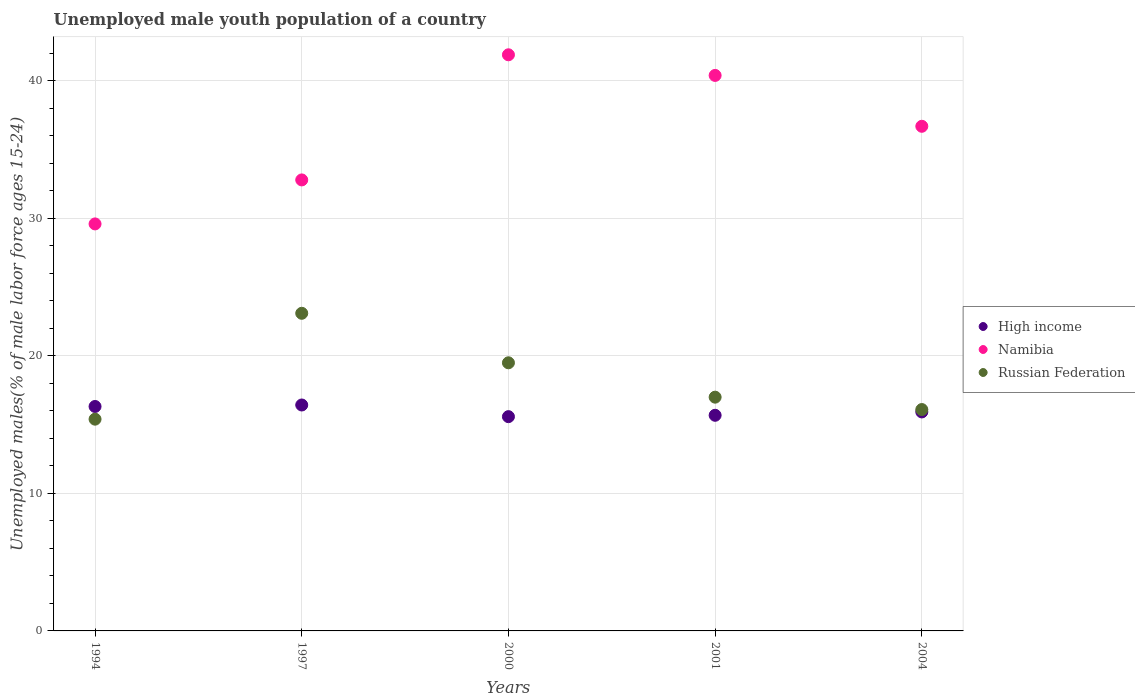Is the number of dotlines equal to the number of legend labels?
Ensure brevity in your answer.  Yes. What is the percentage of unemployed male youth population in High income in 2000?
Your response must be concise. 15.58. Across all years, what is the maximum percentage of unemployed male youth population in High income?
Give a very brief answer. 16.43. Across all years, what is the minimum percentage of unemployed male youth population in High income?
Provide a succinct answer. 15.58. What is the total percentage of unemployed male youth population in High income in the graph?
Offer a terse response. 79.95. What is the difference between the percentage of unemployed male youth population in Russian Federation in 1994 and that in 2000?
Ensure brevity in your answer.  -4.1. What is the difference between the percentage of unemployed male youth population in High income in 2001 and the percentage of unemployed male youth population in Namibia in 2000?
Give a very brief answer. -26.22. What is the average percentage of unemployed male youth population in Russian Federation per year?
Your answer should be compact. 18.22. In the year 1997, what is the difference between the percentage of unemployed male youth population in Russian Federation and percentage of unemployed male youth population in High income?
Make the answer very short. 6.67. In how many years, is the percentage of unemployed male youth population in Russian Federation greater than 12 %?
Ensure brevity in your answer.  5. What is the ratio of the percentage of unemployed male youth population in Russian Federation in 1994 to that in 2000?
Offer a very short reply. 0.79. What is the difference between the highest and the second highest percentage of unemployed male youth population in Russian Federation?
Your answer should be compact. 3.6. What is the difference between the highest and the lowest percentage of unemployed male youth population in Namibia?
Your answer should be very brief. 12.3. Is the sum of the percentage of unemployed male youth population in Namibia in 2000 and 2004 greater than the maximum percentage of unemployed male youth population in High income across all years?
Your response must be concise. Yes. Is the percentage of unemployed male youth population in High income strictly less than the percentage of unemployed male youth population in Namibia over the years?
Your response must be concise. Yes. How many years are there in the graph?
Make the answer very short. 5. What is the difference between two consecutive major ticks on the Y-axis?
Offer a very short reply. 10. Does the graph contain any zero values?
Ensure brevity in your answer.  No. Does the graph contain grids?
Make the answer very short. Yes. Where does the legend appear in the graph?
Your answer should be compact. Center right. How are the legend labels stacked?
Provide a short and direct response. Vertical. What is the title of the graph?
Your response must be concise. Unemployed male youth population of a country. Does "Norway" appear as one of the legend labels in the graph?
Provide a short and direct response. No. What is the label or title of the X-axis?
Keep it short and to the point. Years. What is the label or title of the Y-axis?
Give a very brief answer. Unemployed males(% of male labor force ages 15-24). What is the Unemployed males(% of male labor force ages 15-24) of High income in 1994?
Offer a terse response. 16.32. What is the Unemployed males(% of male labor force ages 15-24) in Namibia in 1994?
Provide a short and direct response. 29.6. What is the Unemployed males(% of male labor force ages 15-24) in Russian Federation in 1994?
Your answer should be very brief. 15.4. What is the Unemployed males(% of male labor force ages 15-24) in High income in 1997?
Keep it short and to the point. 16.43. What is the Unemployed males(% of male labor force ages 15-24) in Namibia in 1997?
Ensure brevity in your answer.  32.8. What is the Unemployed males(% of male labor force ages 15-24) of Russian Federation in 1997?
Make the answer very short. 23.1. What is the Unemployed males(% of male labor force ages 15-24) of High income in 2000?
Your answer should be compact. 15.58. What is the Unemployed males(% of male labor force ages 15-24) in Namibia in 2000?
Offer a very short reply. 41.9. What is the Unemployed males(% of male labor force ages 15-24) in High income in 2001?
Your answer should be compact. 15.68. What is the Unemployed males(% of male labor force ages 15-24) of Namibia in 2001?
Keep it short and to the point. 40.4. What is the Unemployed males(% of male labor force ages 15-24) of Russian Federation in 2001?
Offer a very short reply. 17. What is the Unemployed males(% of male labor force ages 15-24) in High income in 2004?
Make the answer very short. 15.93. What is the Unemployed males(% of male labor force ages 15-24) in Namibia in 2004?
Your response must be concise. 36.7. What is the Unemployed males(% of male labor force ages 15-24) of Russian Federation in 2004?
Your response must be concise. 16.1. Across all years, what is the maximum Unemployed males(% of male labor force ages 15-24) in High income?
Provide a succinct answer. 16.43. Across all years, what is the maximum Unemployed males(% of male labor force ages 15-24) of Namibia?
Your answer should be very brief. 41.9. Across all years, what is the maximum Unemployed males(% of male labor force ages 15-24) in Russian Federation?
Offer a terse response. 23.1. Across all years, what is the minimum Unemployed males(% of male labor force ages 15-24) of High income?
Ensure brevity in your answer.  15.58. Across all years, what is the minimum Unemployed males(% of male labor force ages 15-24) in Namibia?
Your answer should be compact. 29.6. Across all years, what is the minimum Unemployed males(% of male labor force ages 15-24) in Russian Federation?
Ensure brevity in your answer.  15.4. What is the total Unemployed males(% of male labor force ages 15-24) in High income in the graph?
Offer a very short reply. 79.95. What is the total Unemployed males(% of male labor force ages 15-24) of Namibia in the graph?
Your response must be concise. 181.4. What is the total Unemployed males(% of male labor force ages 15-24) of Russian Federation in the graph?
Give a very brief answer. 91.1. What is the difference between the Unemployed males(% of male labor force ages 15-24) of High income in 1994 and that in 1997?
Give a very brief answer. -0.11. What is the difference between the Unemployed males(% of male labor force ages 15-24) of High income in 1994 and that in 2000?
Your answer should be compact. 0.74. What is the difference between the Unemployed males(% of male labor force ages 15-24) of Russian Federation in 1994 and that in 2000?
Your response must be concise. -4.1. What is the difference between the Unemployed males(% of male labor force ages 15-24) in High income in 1994 and that in 2001?
Keep it short and to the point. 0.64. What is the difference between the Unemployed males(% of male labor force ages 15-24) in High income in 1994 and that in 2004?
Your answer should be compact. 0.4. What is the difference between the Unemployed males(% of male labor force ages 15-24) of High income in 1997 and that in 2000?
Your answer should be compact. 0.85. What is the difference between the Unemployed males(% of male labor force ages 15-24) in High income in 1997 and that in 2001?
Your answer should be compact. 0.75. What is the difference between the Unemployed males(% of male labor force ages 15-24) in Namibia in 1997 and that in 2001?
Provide a succinct answer. -7.6. What is the difference between the Unemployed males(% of male labor force ages 15-24) of High income in 1997 and that in 2004?
Provide a short and direct response. 0.51. What is the difference between the Unemployed males(% of male labor force ages 15-24) in Russian Federation in 1997 and that in 2004?
Offer a very short reply. 7. What is the difference between the Unemployed males(% of male labor force ages 15-24) in High income in 2000 and that in 2001?
Your answer should be compact. -0.1. What is the difference between the Unemployed males(% of male labor force ages 15-24) in Namibia in 2000 and that in 2001?
Offer a terse response. 1.5. What is the difference between the Unemployed males(% of male labor force ages 15-24) in Russian Federation in 2000 and that in 2001?
Your answer should be compact. 2.5. What is the difference between the Unemployed males(% of male labor force ages 15-24) of High income in 2000 and that in 2004?
Offer a very short reply. -0.34. What is the difference between the Unemployed males(% of male labor force ages 15-24) of Namibia in 2000 and that in 2004?
Provide a succinct answer. 5.2. What is the difference between the Unemployed males(% of male labor force ages 15-24) of Russian Federation in 2000 and that in 2004?
Keep it short and to the point. 3.4. What is the difference between the Unemployed males(% of male labor force ages 15-24) in High income in 2001 and that in 2004?
Provide a short and direct response. -0.24. What is the difference between the Unemployed males(% of male labor force ages 15-24) in Russian Federation in 2001 and that in 2004?
Provide a short and direct response. 0.9. What is the difference between the Unemployed males(% of male labor force ages 15-24) in High income in 1994 and the Unemployed males(% of male labor force ages 15-24) in Namibia in 1997?
Offer a terse response. -16.48. What is the difference between the Unemployed males(% of male labor force ages 15-24) in High income in 1994 and the Unemployed males(% of male labor force ages 15-24) in Russian Federation in 1997?
Make the answer very short. -6.78. What is the difference between the Unemployed males(% of male labor force ages 15-24) of High income in 1994 and the Unemployed males(% of male labor force ages 15-24) of Namibia in 2000?
Provide a short and direct response. -25.58. What is the difference between the Unemployed males(% of male labor force ages 15-24) of High income in 1994 and the Unemployed males(% of male labor force ages 15-24) of Russian Federation in 2000?
Ensure brevity in your answer.  -3.18. What is the difference between the Unemployed males(% of male labor force ages 15-24) in High income in 1994 and the Unemployed males(% of male labor force ages 15-24) in Namibia in 2001?
Make the answer very short. -24.08. What is the difference between the Unemployed males(% of male labor force ages 15-24) in High income in 1994 and the Unemployed males(% of male labor force ages 15-24) in Russian Federation in 2001?
Your answer should be very brief. -0.68. What is the difference between the Unemployed males(% of male labor force ages 15-24) in Namibia in 1994 and the Unemployed males(% of male labor force ages 15-24) in Russian Federation in 2001?
Give a very brief answer. 12.6. What is the difference between the Unemployed males(% of male labor force ages 15-24) in High income in 1994 and the Unemployed males(% of male labor force ages 15-24) in Namibia in 2004?
Offer a very short reply. -20.38. What is the difference between the Unemployed males(% of male labor force ages 15-24) in High income in 1994 and the Unemployed males(% of male labor force ages 15-24) in Russian Federation in 2004?
Provide a succinct answer. 0.22. What is the difference between the Unemployed males(% of male labor force ages 15-24) in Namibia in 1994 and the Unemployed males(% of male labor force ages 15-24) in Russian Federation in 2004?
Keep it short and to the point. 13.5. What is the difference between the Unemployed males(% of male labor force ages 15-24) of High income in 1997 and the Unemployed males(% of male labor force ages 15-24) of Namibia in 2000?
Ensure brevity in your answer.  -25.47. What is the difference between the Unemployed males(% of male labor force ages 15-24) of High income in 1997 and the Unemployed males(% of male labor force ages 15-24) of Russian Federation in 2000?
Offer a terse response. -3.07. What is the difference between the Unemployed males(% of male labor force ages 15-24) of High income in 1997 and the Unemployed males(% of male labor force ages 15-24) of Namibia in 2001?
Provide a succinct answer. -23.97. What is the difference between the Unemployed males(% of male labor force ages 15-24) in High income in 1997 and the Unemployed males(% of male labor force ages 15-24) in Russian Federation in 2001?
Give a very brief answer. -0.57. What is the difference between the Unemployed males(% of male labor force ages 15-24) of Namibia in 1997 and the Unemployed males(% of male labor force ages 15-24) of Russian Federation in 2001?
Your answer should be compact. 15.8. What is the difference between the Unemployed males(% of male labor force ages 15-24) of High income in 1997 and the Unemployed males(% of male labor force ages 15-24) of Namibia in 2004?
Make the answer very short. -20.27. What is the difference between the Unemployed males(% of male labor force ages 15-24) of High income in 1997 and the Unemployed males(% of male labor force ages 15-24) of Russian Federation in 2004?
Ensure brevity in your answer.  0.33. What is the difference between the Unemployed males(% of male labor force ages 15-24) of Namibia in 1997 and the Unemployed males(% of male labor force ages 15-24) of Russian Federation in 2004?
Your answer should be very brief. 16.7. What is the difference between the Unemployed males(% of male labor force ages 15-24) of High income in 2000 and the Unemployed males(% of male labor force ages 15-24) of Namibia in 2001?
Give a very brief answer. -24.82. What is the difference between the Unemployed males(% of male labor force ages 15-24) in High income in 2000 and the Unemployed males(% of male labor force ages 15-24) in Russian Federation in 2001?
Your answer should be compact. -1.42. What is the difference between the Unemployed males(% of male labor force ages 15-24) of Namibia in 2000 and the Unemployed males(% of male labor force ages 15-24) of Russian Federation in 2001?
Give a very brief answer. 24.9. What is the difference between the Unemployed males(% of male labor force ages 15-24) of High income in 2000 and the Unemployed males(% of male labor force ages 15-24) of Namibia in 2004?
Ensure brevity in your answer.  -21.12. What is the difference between the Unemployed males(% of male labor force ages 15-24) of High income in 2000 and the Unemployed males(% of male labor force ages 15-24) of Russian Federation in 2004?
Provide a succinct answer. -0.52. What is the difference between the Unemployed males(% of male labor force ages 15-24) of Namibia in 2000 and the Unemployed males(% of male labor force ages 15-24) of Russian Federation in 2004?
Offer a very short reply. 25.8. What is the difference between the Unemployed males(% of male labor force ages 15-24) in High income in 2001 and the Unemployed males(% of male labor force ages 15-24) in Namibia in 2004?
Provide a short and direct response. -21.02. What is the difference between the Unemployed males(% of male labor force ages 15-24) of High income in 2001 and the Unemployed males(% of male labor force ages 15-24) of Russian Federation in 2004?
Offer a very short reply. -0.42. What is the difference between the Unemployed males(% of male labor force ages 15-24) in Namibia in 2001 and the Unemployed males(% of male labor force ages 15-24) in Russian Federation in 2004?
Offer a terse response. 24.3. What is the average Unemployed males(% of male labor force ages 15-24) of High income per year?
Ensure brevity in your answer.  15.99. What is the average Unemployed males(% of male labor force ages 15-24) of Namibia per year?
Your response must be concise. 36.28. What is the average Unemployed males(% of male labor force ages 15-24) of Russian Federation per year?
Give a very brief answer. 18.22. In the year 1994, what is the difference between the Unemployed males(% of male labor force ages 15-24) of High income and Unemployed males(% of male labor force ages 15-24) of Namibia?
Your answer should be very brief. -13.28. In the year 1994, what is the difference between the Unemployed males(% of male labor force ages 15-24) in High income and Unemployed males(% of male labor force ages 15-24) in Russian Federation?
Your answer should be compact. 0.92. In the year 1994, what is the difference between the Unemployed males(% of male labor force ages 15-24) in Namibia and Unemployed males(% of male labor force ages 15-24) in Russian Federation?
Provide a short and direct response. 14.2. In the year 1997, what is the difference between the Unemployed males(% of male labor force ages 15-24) in High income and Unemployed males(% of male labor force ages 15-24) in Namibia?
Make the answer very short. -16.37. In the year 1997, what is the difference between the Unemployed males(% of male labor force ages 15-24) of High income and Unemployed males(% of male labor force ages 15-24) of Russian Federation?
Your answer should be compact. -6.67. In the year 2000, what is the difference between the Unemployed males(% of male labor force ages 15-24) of High income and Unemployed males(% of male labor force ages 15-24) of Namibia?
Give a very brief answer. -26.32. In the year 2000, what is the difference between the Unemployed males(% of male labor force ages 15-24) in High income and Unemployed males(% of male labor force ages 15-24) in Russian Federation?
Your answer should be very brief. -3.92. In the year 2000, what is the difference between the Unemployed males(% of male labor force ages 15-24) in Namibia and Unemployed males(% of male labor force ages 15-24) in Russian Federation?
Offer a terse response. 22.4. In the year 2001, what is the difference between the Unemployed males(% of male labor force ages 15-24) in High income and Unemployed males(% of male labor force ages 15-24) in Namibia?
Offer a terse response. -24.72. In the year 2001, what is the difference between the Unemployed males(% of male labor force ages 15-24) of High income and Unemployed males(% of male labor force ages 15-24) of Russian Federation?
Your response must be concise. -1.32. In the year 2001, what is the difference between the Unemployed males(% of male labor force ages 15-24) of Namibia and Unemployed males(% of male labor force ages 15-24) of Russian Federation?
Offer a terse response. 23.4. In the year 2004, what is the difference between the Unemployed males(% of male labor force ages 15-24) in High income and Unemployed males(% of male labor force ages 15-24) in Namibia?
Offer a terse response. -20.77. In the year 2004, what is the difference between the Unemployed males(% of male labor force ages 15-24) in High income and Unemployed males(% of male labor force ages 15-24) in Russian Federation?
Keep it short and to the point. -0.17. In the year 2004, what is the difference between the Unemployed males(% of male labor force ages 15-24) in Namibia and Unemployed males(% of male labor force ages 15-24) in Russian Federation?
Offer a very short reply. 20.6. What is the ratio of the Unemployed males(% of male labor force ages 15-24) in Namibia in 1994 to that in 1997?
Your answer should be compact. 0.9. What is the ratio of the Unemployed males(% of male labor force ages 15-24) of Russian Federation in 1994 to that in 1997?
Offer a terse response. 0.67. What is the ratio of the Unemployed males(% of male labor force ages 15-24) of High income in 1994 to that in 2000?
Ensure brevity in your answer.  1.05. What is the ratio of the Unemployed males(% of male labor force ages 15-24) of Namibia in 1994 to that in 2000?
Offer a very short reply. 0.71. What is the ratio of the Unemployed males(% of male labor force ages 15-24) in Russian Federation in 1994 to that in 2000?
Provide a short and direct response. 0.79. What is the ratio of the Unemployed males(% of male labor force ages 15-24) of High income in 1994 to that in 2001?
Provide a short and direct response. 1.04. What is the ratio of the Unemployed males(% of male labor force ages 15-24) of Namibia in 1994 to that in 2001?
Provide a short and direct response. 0.73. What is the ratio of the Unemployed males(% of male labor force ages 15-24) in Russian Federation in 1994 to that in 2001?
Keep it short and to the point. 0.91. What is the ratio of the Unemployed males(% of male labor force ages 15-24) in High income in 1994 to that in 2004?
Make the answer very short. 1.02. What is the ratio of the Unemployed males(% of male labor force ages 15-24) in Namibia in 1994 to that in 2004?
Your answer should be compact. 0.81. What is the ratio of the Unemployed males(% of male labor force ages 15-24) of Russian Federation in 1994 to that in 2004?
Ensure brevity in your answer.  0.96. What is the ratio of the Unemployed males(% of male labor force ages 15-24) of High income in 1997 to that in 2000?
Keep it short and to the point. 1.05. What is the ratio of the Unemployed males(% of male labor force ages 15-24) in Namibia in 1997 to that in 2000?
Make the answer very short. 0.78. What is the ratio of the Unemployed males(% of male labor force ages 15-24) in Russian Federation in 1997 to that in 2000?
Offer a terse response. 1.18. What is the ratio of the Unemployed males(% of male labor force ages 15-24) in High income in 1997 to that in 2001?
Your answer should be very brief. 1.05. What is the ratio of the Unemployed males(% of male labor force ages 15-24) of Namibia in 1997 to that in 2001?
Your answer should be compact. 0.81. What is the ratio of the Unemployed males(% of male labor force ages 15-24) of Russian Federation in 1997 to that in 2001?
Your answer should be compact. 1.36. What is the ratio of the Unemployed males(% of male labor force ages 15-24) in High income in 1997 to that in 2004?
Offer a very short reply. 1.03. What is the ratio of the Unemployed males(% of male labor force ages 15-24) of Namibia in 1997 to that in 2004?
Your answer should be compact. 0.89. What is the ratio of the Unemployed males(% of male labor force ages 15-24) in Russian Federation in 1997 to that in 2004?
Provide a short and direct response. 1.43. What is the ratio of the Unemployed males(% of male labor force ages 15-24) in Namibia in 2000 to that in 2001?
Provide a short and direct response. 1.04. What is the ratio of the Unemployed males(% of male labor force ages 15-24) in Russian Federation in 2000 to that in 2001?
Ensure brevity in your answer.  1.15. What is the ratio of the Unemployed males(% of male labor force ages 15-24) of High income in 2000 to that in 2004?
Ensure brevity in your answer.  0.98. What is the ratio of the Unemployed males(% of male labor force ages 15-24) of Namibia in 2000 to that in 2004?
Your answer should be very brief. 1.14. What is the ratio of the Unemployed males(% of male labor force ages 15-24) of Russian Federation in 2000 to that in 2004?
Keep it short and to the point. 1.21. What is the ratio of the Unemployed males(% of male labor force ages 15-24) of High income in 2001 to that in 2004?
Offer a very short reply. 0.98. What is the ratio of the Unemployed males(% of male labor force ages 15-24) in Namibia in 2001 to that in 2004?
Make the answer very short. 1.1. What is the ratio of the Unemployed males(% of male labor force ages 15-24) in Russian Federation in 2001 to that in 2004?
Offer a very short reply. 1.06. What is the difference between the highest and the second highest Unemployed males(% of male labor force ages 15-24) of High income?
Provide a succinct answer. 0.11. What is the difference between the highest and the second highest Unemployed males(% of male labor force ages 15-24) in Russian Federation?
Provide a succinct answer. 3.6. What is the difference between the highest and the lowest Unemployed males(% of male labor force ages 15-24) in High income?
Provide a succinct answer. 0.85. What is the difference between the highest and the lowest Unemployed males(% of male labor force ages 15-24) of Namibia?
Your answer should be very brief. 12.3. What is the difference between the highest and the lowest Unemployed males(% of male labor force ages 15-24) of Russian Federation?
Your answer should be compact. 7.7. 